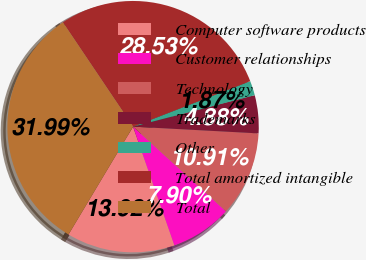<chart> <loc_0><loc_0><loc_500><loc_500><pie_chart><fcel>Computer software products<fcel>Customer relationships<fcel>Technology<fcel>Trademarks<fcel>Other<fcel>Total amortized intangible<fcel>Total<nl><fcel>13.92%<fcel>7.9%<fcel>10.91%<fcel>4.88%<fcel>1.87%<fcel>28.53%<fcel>31.99%<nl></chart> 